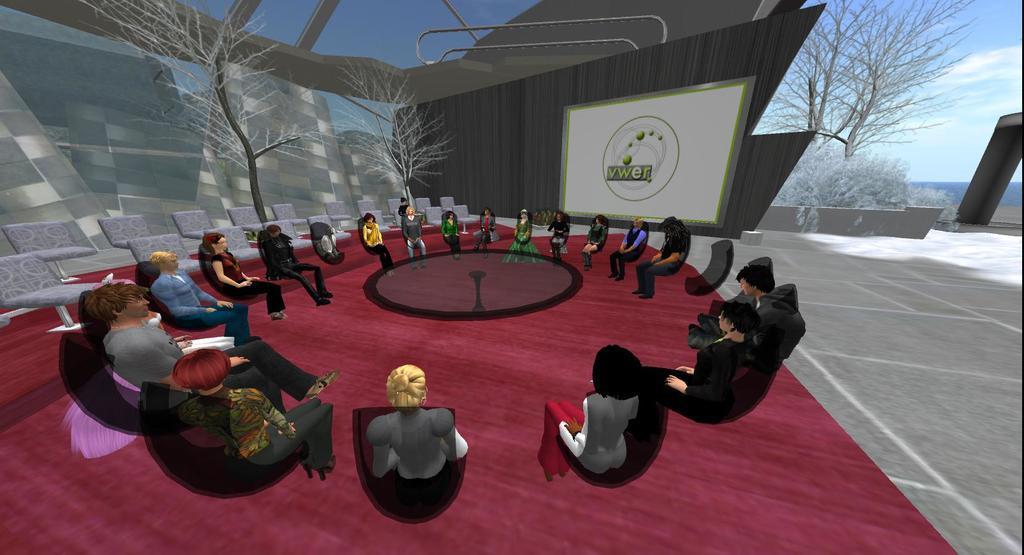How would you summarize this image in a sentence or two? In this picture there is a cartoon image. In the front there is a group of men and women sitting around the table and discussing something. Behind there are some dry trees and white color banner board. 